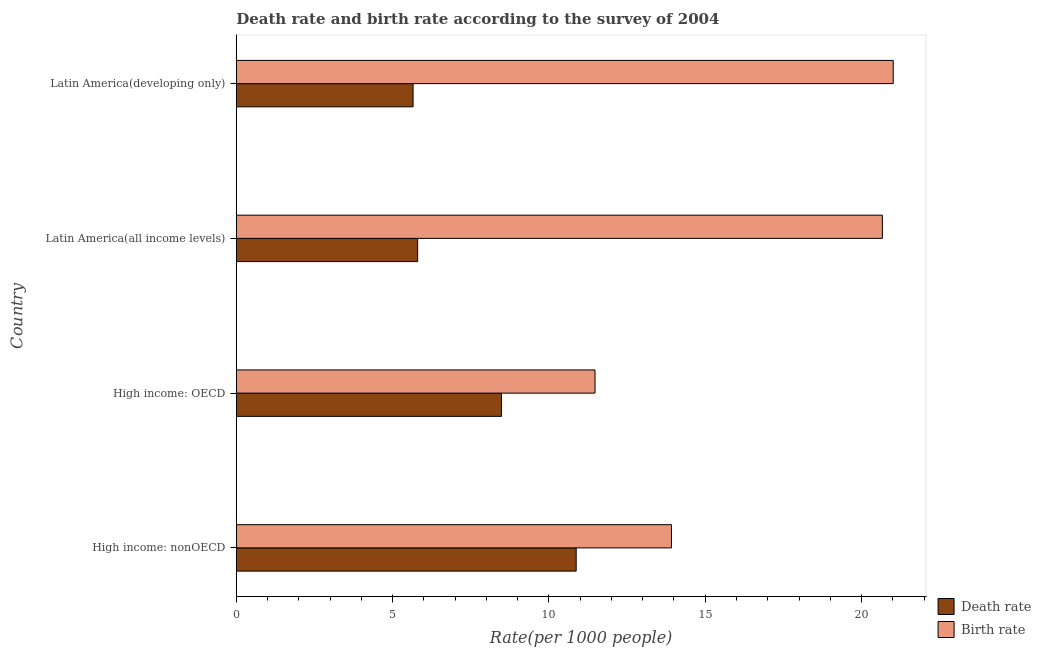Are the number of bars per tick equal to the number of legend labels?
Offer a very short reply. Yes. Are the number of bars on each tick of the Y-axis equal?
Provide a short and direct response. Yes. How many bars are there on the 2nd tick from the bottom?
Your response must be concise. 2. What is the label of the 2nd group of bars from the top?
Offer a terse response. Latin America(all income levels). In how many cases, is the number of bars for a given country not equal to the number of legend labels?
Your response must be concise. 0. What is the birth rate in High income: OECD?
Offer a terse response. 11.47. Across all countries, what is the maximum death rate?
Keep it short and to the point. 10.87. Across all countries, what is the minimum death rate?
Ensure brevity in your answer.  5.66. In which country was the death rate maximum?
Keep it short and to the point. High income: nonOECD. In which country was the birth rate minimum?
Provide a short and direct response. High income: OECD. What is the total birth rate in the graph?
Make the answer very short. 67.07. What is the difference between the birth rate in High income: nonOECD and that in Latin America(developing only)?
Your response must be concise. -7.09. What is the difference between the birth rate in High income: OECD and the death rate in Latin America(all income levels)?
Offer a very short reply. 5.67. What is the average death rate per country?
Offer a terse response. 7.7. What is the difference between the birth rate and death rate in High income: nonOECD?
Ensure brevity in your answer.  3.05. What is the ratio of the birth rate in Latin America(all income levels) to that in Latin America(developing only)?
Give a very brief answer. 0.98. What is the difference between the highest and the second highest birth rate?
Provide a short and direct response. 0.35. What is the difference between the highest and the lowest birth rate?
Provide a short and direct response. 9.54. What does the 1st bar from the top in Latin America(developing only) represents?
Your response must be concise. Birth rate. What does the 1st bar from the bottom in High income: nonOECD represents?
Offer a very short reply. Death rate. Are all the bars in the graph horizontal?
Give a very brief answer. Yes. How many countries are there in the graph?
Make the answer very short. 4. What is the difference between two consecutive major ticks on the X-axis?
Your response must be concise. 5. Are the values on the major ticks of X-axis written in scientific E-notation?
Offer a very short reply. No. Does the graph contain any zero values?
Make the answer very short. No. Where does the legend appear in the graph?
Offer a terse response. Bottom right. What is the title of the graph?
Offer a very short reply. Death rate and birth rate according to the survey of 2004. What is the label or title of the X-axis?
Your response must be concise. Rate(per 1000 people). What is the Rate(per 1000 people) of Death rate in High income: nonOECD?
Your answer should be very brief. 10.87. What is the Rate(per 1000 people) in Birth rate in High income: nonOECD?
Offer a very short reply. 13.92. What is the Rate(per 1000 people) in Death rate in High income: OECD?
Keep it short and to the point. 8.48. What is the Rate(per 1000 people) in Birth rate in High income: OECD?
Offer a terse response. 11.47. What is the Rate(per 1000 people) of Death rate in Latin America(all income levels)?
Keep it short and to the point. 5.8. What is the Rate(per 1000 people) of Birth rate in Latin America(all income levels)?
Ensure brevity in your answer.  20.67. What is the Rate(per 1000 people) of Death rate in Latin America(developing only)?
Offer a very short reply. 5.66. What is the Rate(per 1000 people) in Birth rate in Latin America(developing only)?
Provide a short and direct response. 21.01. Across all countries, what is the maximum Rate(per 1000 people) of Death rate?
Give a very brief answer. 10.87. Across all countries, what is the maximum Rate(per 1000 people) in Birth rate?
Provide a succinct answer. 21.01. Across all countries, what is the minimum Rate(per 1000 people) of Death rate?
Your answer should be very brief. 5.66. Across all countries, what is the minimum Rate(per 1000 people) in Birth rate?
Keep it short and to the point. 11.47. What is the total Rate(per 1000 people) in Death rate in the graph?
Ensure brevity in your answer.  30.81. What is the total Rate(per 1000 people) in Birth rate in the graph?
Provide a short and direct response. 67.07. What is the difference between the Rate(per 1000 people) in Death rate in High income: nonOECD and that in High income: OECD?
Provide a short and direct response. 2.39. What is the difference between the Rate(per 1000 people) in Birth rate in High income: nonOECD and that in High income: OECD?
Provide a succinct answer. 2.44. What is the difference between the Rate(per 1000 people) in Death rate in High income: nonOECD and that in Latin America(all income levels)?
Give a very brief answer. 5.07. What is the difference between the Rate(per 1000 people) of Birth rate in High income: nonOECD and that in Latin America(all income levels)?
Your answer should be very brief. -6.75. What is the difference between the Rate(per 1000 people) in Death rate in High income: nonOECD and that in Latin America(developing only)?
Offer a terse response. 5.22. What is the difference between the Rate(per 1000 people) in Birth rate in High income: nonOECD and that in Latin America(developing only)?
Ensure brevity in your answer.  -7.09. What is the difference between the Rate(per 1000 people) of Death rate in High income: OECD and that in Latin America(all income levels)?
Your response must be concise. 2.68. What is the difference between the Rate(per 1000 people) in Birth rate in High income: OECD and that in Latin America(all income levels)?
Your response must be concise. -9.19. What is the difference between the Rate(per 1000 people) of Death rate in High income: OECD and that in Latin America(developing only)?
Provide a short and direct response. 2.83. What is the difference between the Rate(per 1000 people) in Birth rate in High income: OECD and that in Latin America(developing only)?
Offer a terse response. -9.54. What is the difference between the Rate(per 1000 people) of Death rate in Latin America(all income levels) and that in Latin America(developing only)?
Your response must be concise. 0.15. What is the difference between the Rate(per 1000 people) in Birth rate in Latin America(all income levels) and that in Latin America(developing only)?
Provide a short and direct response. -0.35. What is the difference between the Rate(per 1000 people) in Death rate in High income: nonOECD and the Rate(per 1000 people) in Birth rate in High income: OECD?
Your answer should be compact. -0.6. What is the difference between the Rate(per 1000 people) of Death rate in High income: nonOECD and the Rate(per 1000 people) of Birth rate in Latin America(all income levels)?
Provide a short and direct response. -9.79. What is the difference between the Rate(per 1000 people) of Death rate in High income: nonOECD and the Rate(per 1000 people) of Birth rate in Latin America(developing only)?
Provide a succinct answer. -10.14. What is the difference between the Rate(per 1000 people) of Death rate in High income: OECD and the Rate(per 1000 people) of Birth rate in Latin America(all income levels)?
Make the answer very short. -12.18. What is the difference between the Rate(per 1000 people) of Death rate in High income: OECD and the Rate(per 1000 people) of Birth rate in Latin America(developing only)?
Keep it short and to the point. -12.53. What is the difference between the Rate(per 1000 people) in Death rate in Latin America(all income levels) and the Rate(per 1000 people) in Birth rate in Latin America(developing only)?
Provide a short and direct response. -15.21. What is the average Rate(per 1000 people) of Death rate per country?
Your answer should be very brief. 7.7. What is the average Rate(per 1000 people) in Birth rate per country?
Your answer should be very brief. 16.77. What is the difference between the Rate(per 1000 people) of Death rate and Rate(per 1000 people) of Birth rate in High income: nonOECD?
Your answer should be very brief. -3.05. What is the difference between the Rate(per 1000 people) in Death rate and Rate(per 1000 people) in Birth rate in High income: OECD?
Give a very brief answer. -2.99. What is the difference between the Rate(per 1000 people) in Death rate and Rate(per 1000 people) in Birth rate in Latin America(all income levels)?
Offer a terse response. -14.86. What is the difference between the Rate(per 1000 people) of Death rate and Rate(per 1000 people) of Birth rate in Latin America(developing only)?
Your answer should be very brief. -15.36. What is the ratio of the Rate(per 1000 people) in Death rate in High income: nonOECD to that in High income: OECD?
Ensure brevity in your answer.  1.28. What is the ratio of the Rate(per 1000 people) of Birth rate in High income: nonOECD to that in High income: OECD?
Offer a terse response. 1.21. What is the ratio of the Rate(per 1000 people) in Death rate in High income: nonOECD to that in Latin America(all income levels)?
Give a very brief answer. 1.87. What is the ratio of the Rate(per 1000 people) in Birth rate in High income: nonOECD to that in Latin America(all income levels)?
Your answer should be compact. 0.67. What is the ratio of the Rate(per 1000 people) of Death rate in High income: nonOECD to that in Latin America(developing only)?
Offer a very short reply. 1.92. What is the ratio of the Rate(per 1000 people) of Birth rate in High income: nonOECD to that in Latin America(developing only)?
Give a very brief answer. 0.66. What is the ratio of the Rate(per 1000 people) of Death rate in High income: OECD to that in Latin America(all income levels)?
Provide a succinct answer. 1.46. What is the ratio of the Rate(per 1000 people) of Birth rate in High income: OECD to that in Latin America(all income levels)?
Your answer should be very brief. 0.56. What is the ratio of the Rate(per 1000 people) of Death rate in High income: OECD to that in Latin America(developing only)?
Ensure brevity in your answer.  1.5. What is the ratio of the Rate(per 1000 people) in Birth rate in High income: OECD to that in Latin America(developing only)?
Your answer should be very brief. 0.55. What is the ratio of the Rate(per 1000 people) of Birth rate in Latin America(all income levels) to that in Latin America(developing only)?
Offer a terse response. 0.98. What is the difference between the highest and the second highest Rate(per 1000 people) of Death rate?
Provide a short and direct response. 2.39. What is the difference between the highest and the second highest Rate(per 1000 people) of Birth rate?
Offer a very short reply. 0.35. What is the difference between the highest and the lowest Rate(per 1000 people) in Death rate?
Your answer should be very brief. 5.22. What is the difference between the highest and the lowest Rate(per 1000 people) in Birth rate?
Ensure brevity in your answer.  9.54. 